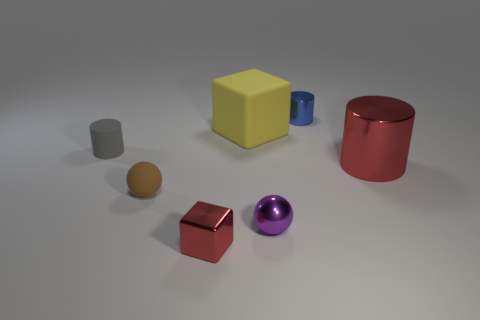Add 1 green metal spheres. How many objects exist? 8 Subtract all tiny cylinders. How many cylinders are left? 1 Subtract all cubes. How many objects are left? 5 Subtract 0 purple blocks. How many objects are left? 7 Subtract all yellow balls. Subtract all red cylinders. How many balls are left? 2 Subtract all small rubber things. Subtract all large gray rubber cylinders. How many objects are left? 5 Add 1 tiny blocks. How many tiny blocks are left? 2 Add 2 tiny gray objects. How many tiny gray objects exist? 3 